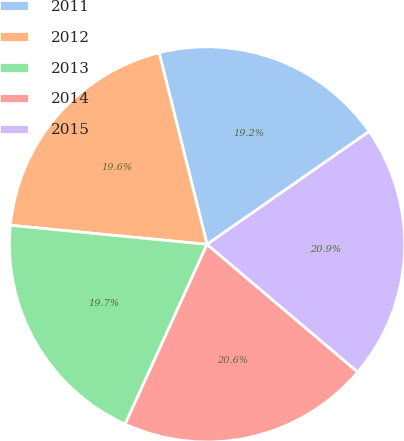Convert chart to OTSL. <chart><loc_0><loc_0><loc_500><loc_500><pie_chart><fcel>2011<fcel>2012<fcel>2013<fcel>2014<fcel>2015<nl><fcel>19.22%<fcel>19.56%<fcel>19.73%<fcel>20.62%<fcel>20.87%<nl></chart> 